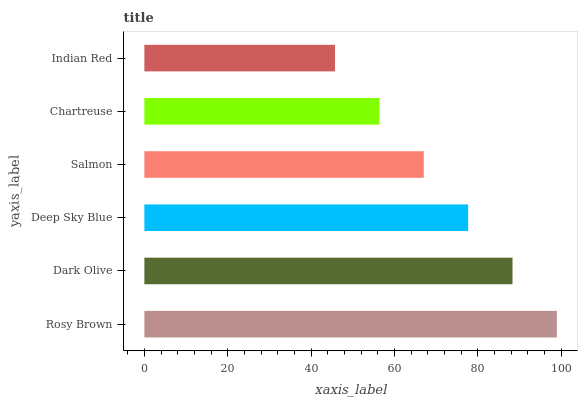Is Indian Red the minimum?
Answer yes or no. Yes. Is Rosy Brown the maximum?
Answer yes or no. Yes. Is Dark Olive the minimum?
Answer yes or no. No. Is Dark Olive the maximum?
Answer yes or no. No. Is Rosy Brown greater than Dark Olive?
Answer yes or no. Yes. Is Dark Olive less than Rosy Brown?
Answer yes or no. Yes. Is Dark Olive greater than Rosy Brown?
Answer yes or no. No. Is Rosy Brown less than Dark Olive?
Answer yes or no. No. Is Deep Sky Blue the high median?
Answer yes or no. Yes. Is Salmon the low median?
Answer yes or no. Yes. Is Rosy Brown the high median?
Answer yes or no. No. Is Deep Sky Blue the low median?
Answer yes or no. No. 